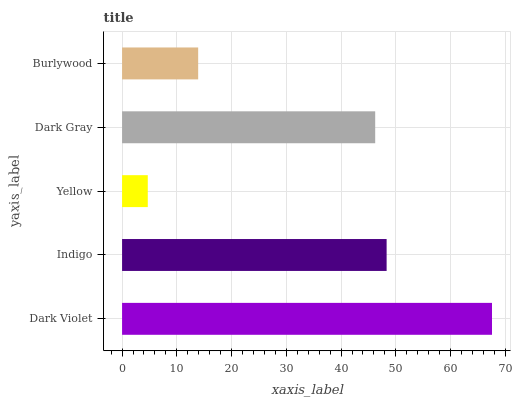Is Yellow the minimum?
Answer yes or no. Yes. Is Dark Violet the maximum?
Answer yes or no. Yes. Is Indigo the minimum?
Answer yes or no. No. Is Indigo the maximum?
Answer yes or no. No. Is Dark Violet greater than Indigo?
Answer yes or no. Yes. Is Indigo less than Dark Violet?
Answer yes or no. Yes. Is Indigo greater than Dark Violet?
Answer yes or no. No. Is Dark Violet less than Indigo?
Answer yes or no. No. Is Dark Gray the high median?
Answer yes or no. Yes. Is Dark Gray the low median?
Answer yes or no. Yes. Is Dark Violet the high median?
Answer yes or no. No. Is Yellow the low median?
Answer yes or no. No. 